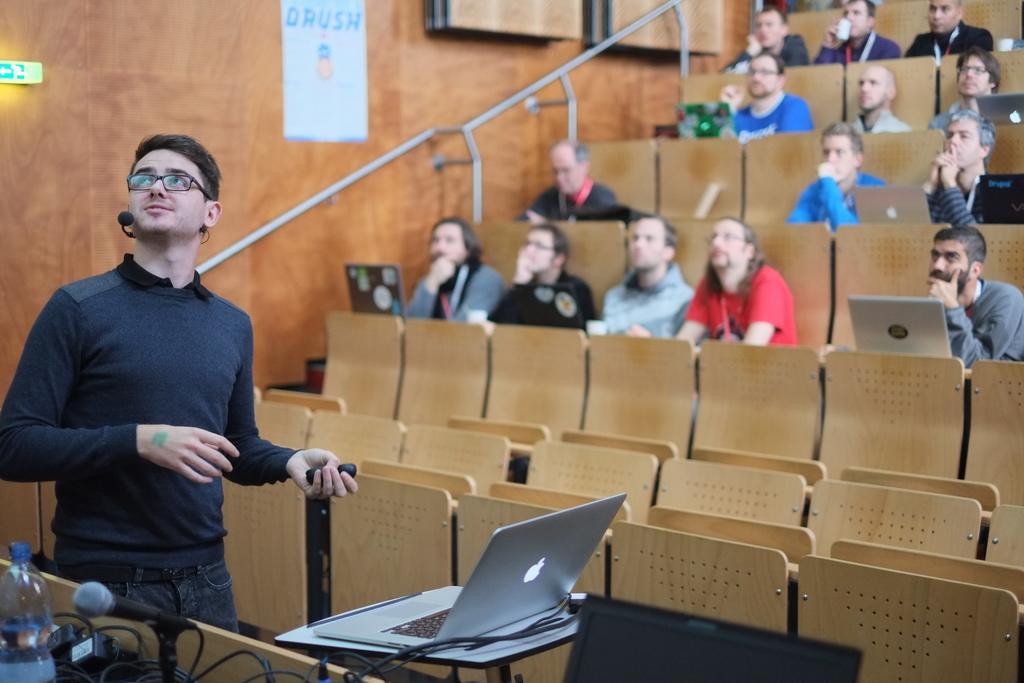How would you summarize this image in a sentence or two? In this picture there are some people sitting in the chairs in front of a laptop placed on their respective tables. There is a man standing with a mic in front of a laptop. In the background, we can observe a paper stuck to the wall here. 